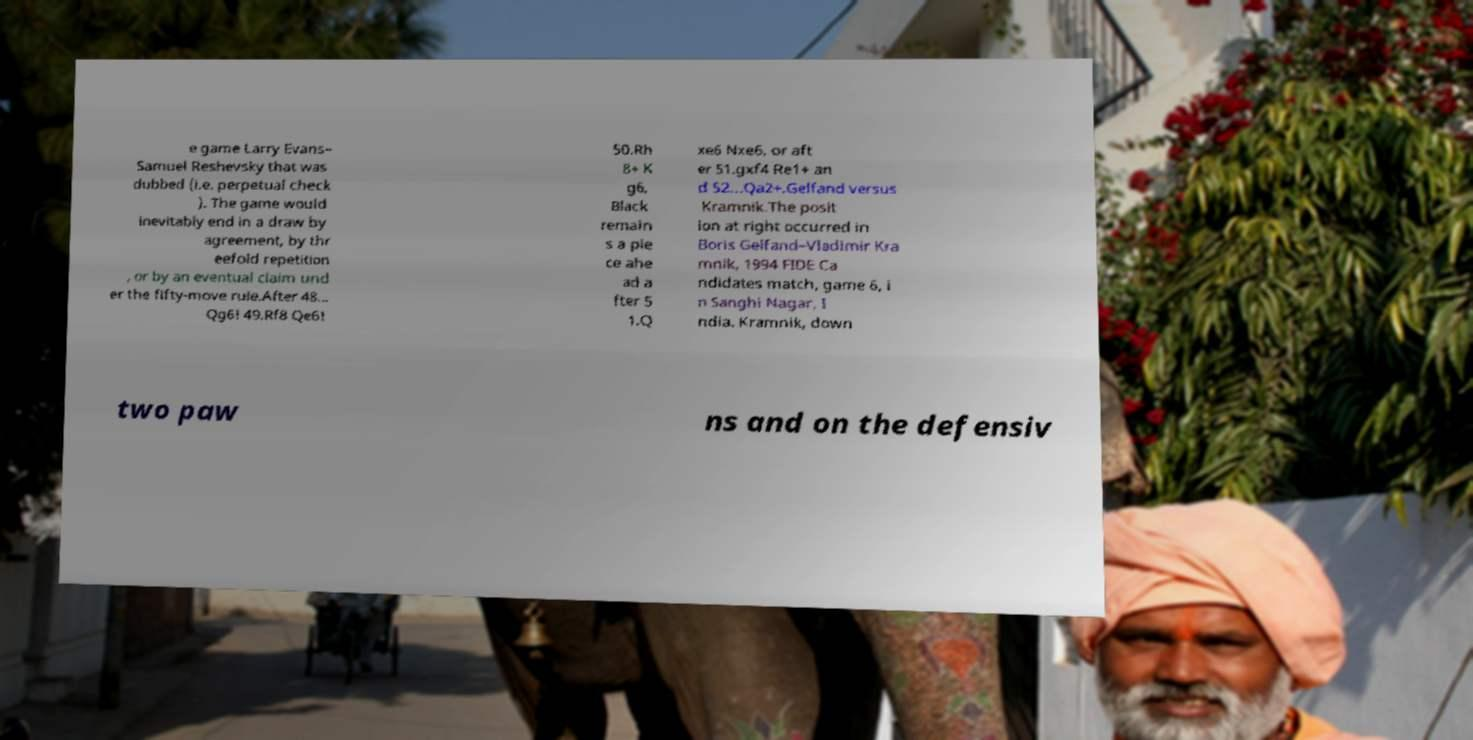Could you extract and type out the text from this image? e game Larry Evans– Samuel Reshevsky that was dubbed (i.e. perpetual check ). The game would inevitably end in a draw by agreement, by thr eefold repetition , or by an eventual claim und er the fifty-move rule.After 48... Qg6! 49.Rf8 Qe6! 50.Rh 8+ K g6, Black remain s a pie ce ahe ad a fter 5 1.Q xe6 Nxe6, or aft er 51.gxf4 Re1+ an d 52...Qa2+.Gelfand versus Kramnik.The posit ion at right occurred in Boris Gelfand–Vladimir Kra mnik, 1994 FIDE Ca ndidates match, game 6, i n Sanghi Nagar, I ndia. Kramnik, down two paw ns and on the defensiv 